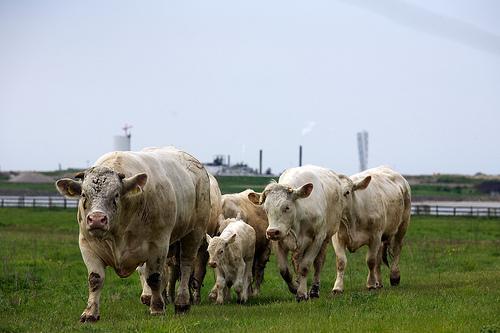How many cows are there?
Give a very brief answer. 6. How many of the cows are babies?
Give a very brief answer. 1. 